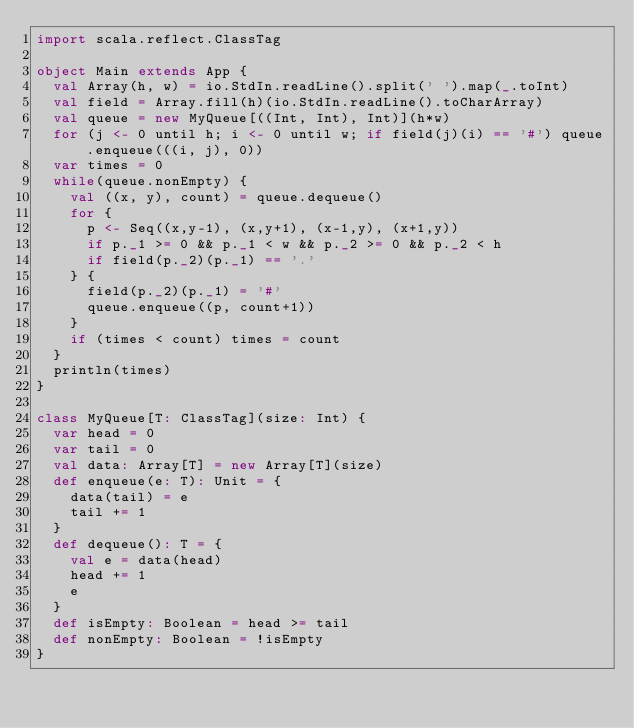<code> <loc_0><loc_0><loc_500><loc_500><_Scala_>import scala.reflect.ClassTag

object Main extends App {
  val Array(h, w) = io.StdIn.readLine().split(' ').map(_.toInt)
  val field = Array.fill(h)(io.StdIn.readLine().toCharArray)
  val queue = new MyQueue[((Int, Int), Int)](h*w)
  for (j <- 0 until h; i <- 0 until w; if field(j)(i) == '#') queue.enqueue(((i, j), 0))
  var times = 0
  while(queue.nonEmpty) {
    val ((x, y), count) = queue.dequeue()
    for {
      p <- Seq((x,y-1), (x,y+1), (x-1,y), (x+1,y))
      if p._1 >= 0 && p._1 < w && p._2 >= 0 && p._2 < h
      if field(p._2)(p._1) == '.'
    } {
      field(p._2)(p._1) = '#'
      queue.enqueue((p, count+1))
    }
    if (times < count) times = count
  }
  println(times)
}

class MyQueue[T: ClassTag](size: Int) {
  var head = 0
  var tail = 0
  val data: Array[T] = new Array[T](size)
  def enqueue(e: T): Unit = {
    data(tail) = e
    tail += 1
  }
  def dequeue(): T = {
    val e = data(head)
    head += 1
    e
  }
  def isEmpty: Boolean = head >= tail
  def nonEmpty: Boolean = !isEmpty
}</code> 